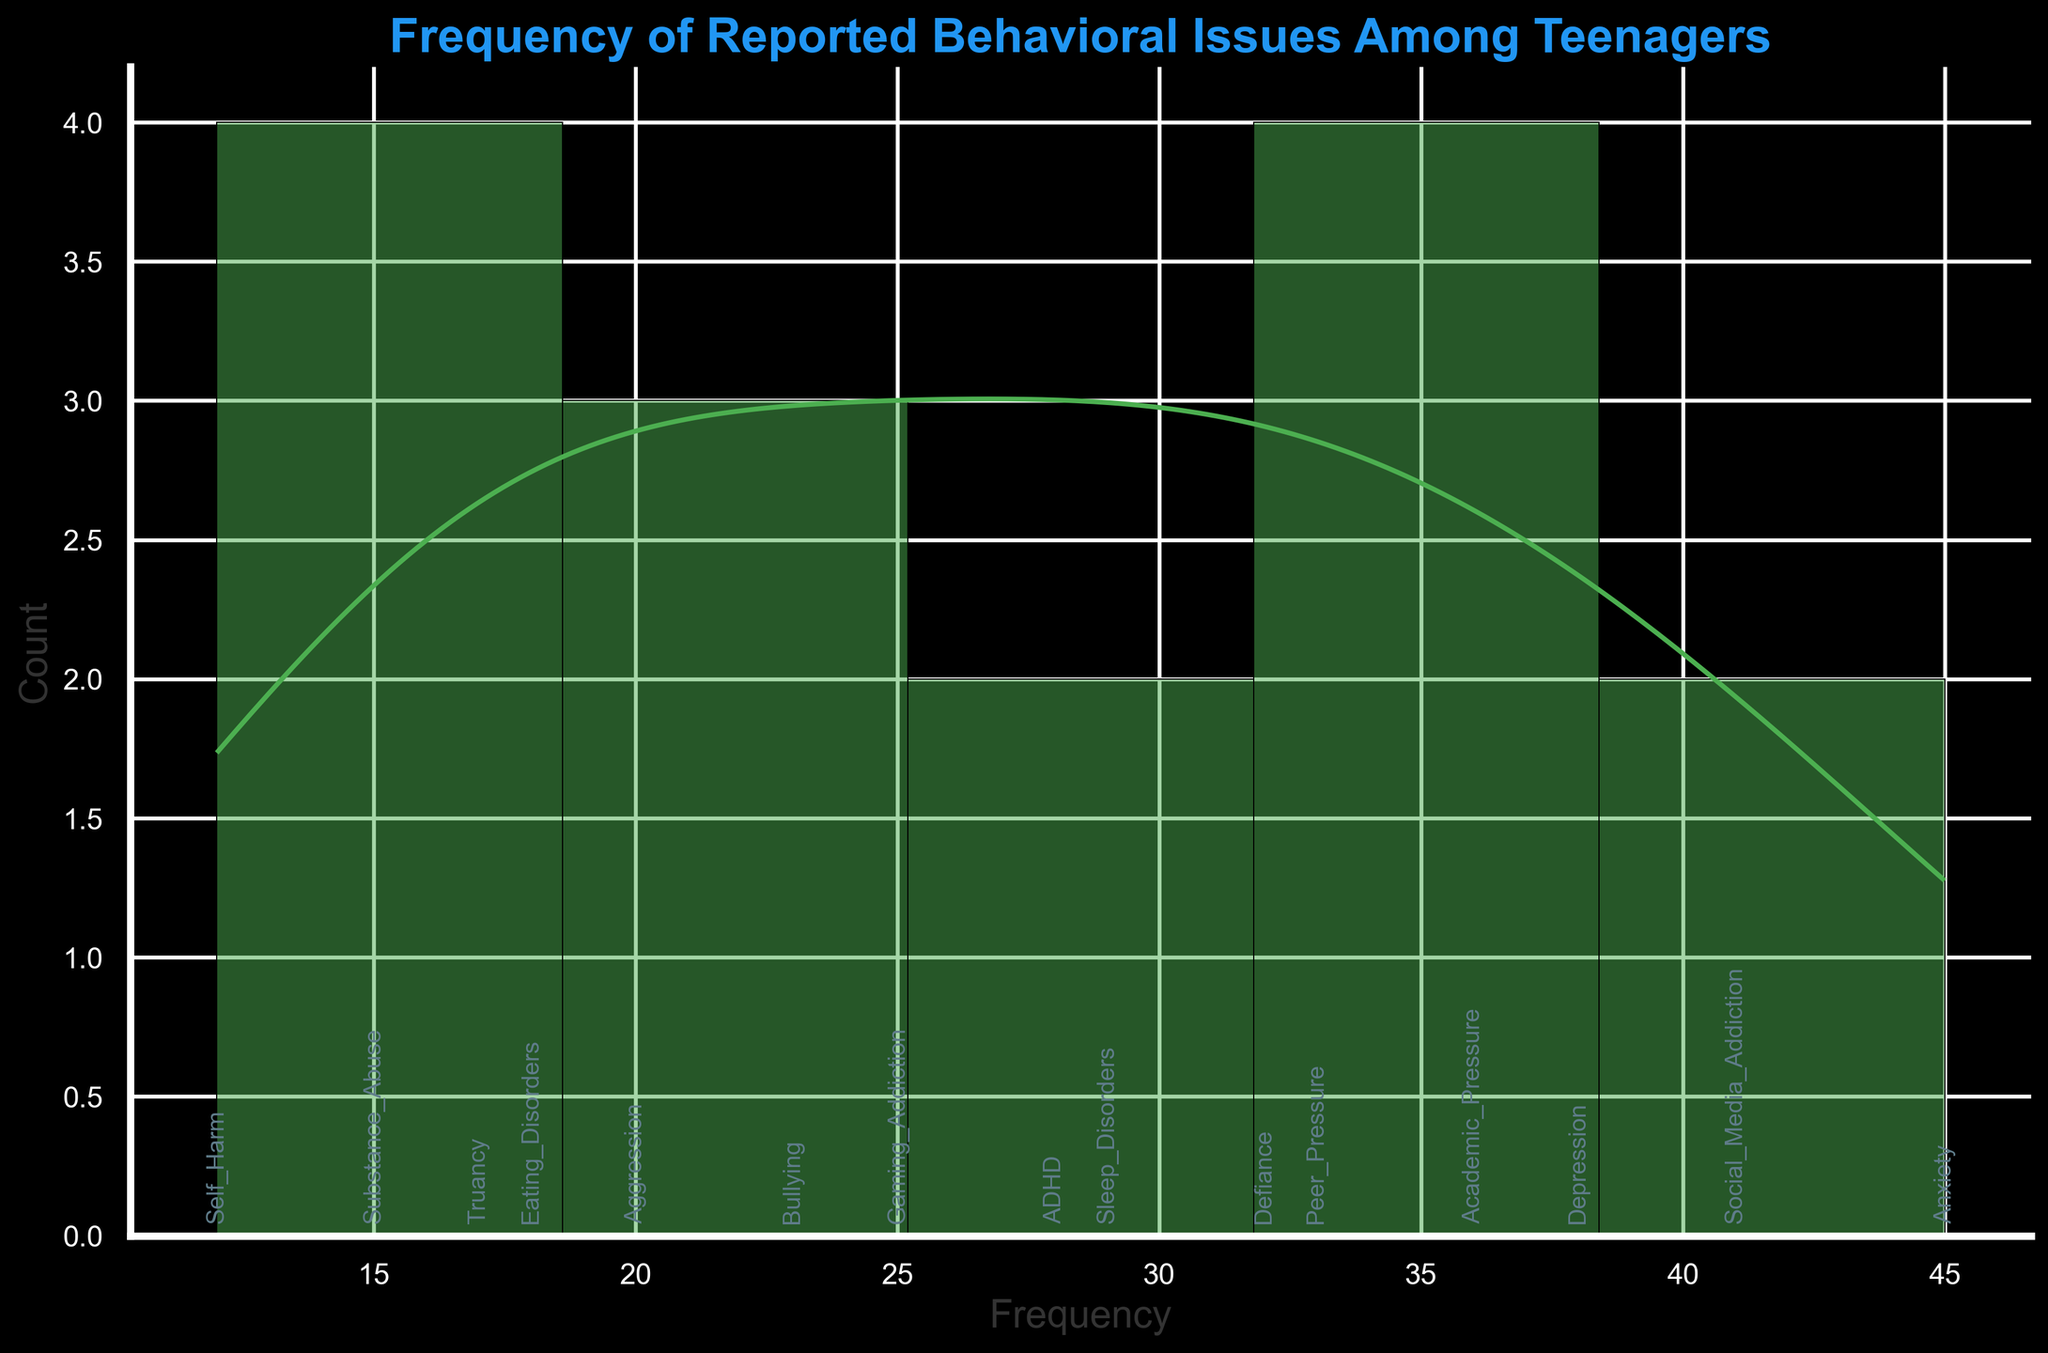What's the title of the figure? The title is typically located at the top of the plot. By looking at the top of the histogram with the KDE curve, we can see the fully displayed title.
Answer: Frequency of Reported Behavioral Issues Among Teenagers What is the maximum frequency reported, and which issue does it correspond to? The highest bar on the histogram represents the maximum frequency. By looking at the bars and their corresponding annotations, the issue with the highest frequency can be identified.
Answer: 45, Anxiety How many behavioral issues have a frequency greater than 30? Identify all bars with frequencies above 30, and count each instance. The annotations above each bar will help confirm the issues related to those frequencies.
Answer: 6 What's the range of frequencies for the reported behavioral issues? To find the range, identify the minimum and maximum frequency values from the x-axis and then subtract the minimum from the maximum.
Answer: 12 to 45 (33) How does the frequency of ADHD compare to that of Aggression? Locate the bars annoted as ADHD and Aggression. Note the height of these bars to determine their respective frequencies. Compare the frequencies to see which is greater.
Answer: ADHD: 28, Aggression: 20. ADHD is higher Which behavioral issue is just below the bar for Social Media Addiction in frequency? Find the bar annotated as Social Media Addiction, which has a frequency of 41. Identify the issue annotated just below it.
Answer: Depression, 38 What is the density curve's color, and how does it visually help in the histogram? The density curve overlies the histogram, represented by a distinct color from the bars. This curve helps smooth out the frequencies and gives a sense of distribution shape.
Answer: Orange. It helps visualize the data distribution trend What percentage of behavioral issues have a frequency between 20 and 40? Count the number of issues with frequencies between 20 and 40. There are 15 issues in total. Divide the count by the total number of issues and multiply by 100.
Answer: (12/15) * 100 = 80% Which issue has a frequency closest to the average frequency of all issues? Sum all frequencies and divide by the number of issues to get the average. Identify the issue whose frequency is nearest to this average.
Answer: Average frequency = (437/15) ≈ 29.13, Closest = Sleep Disorders, 29 How does the visual annotation at the top of each bar help in interpreting the data? The annotations mark the exact behavioral issue each bar represents, enhancing clarity and aiding quick identification without rechecking the dataset.
Answer: It helps in quick identification and clarity 